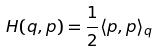<formula> <loc_0><loc_0><loc_500><loc_500>H ( q , p ) = \frac { 1 } { 2 } \langle p , p \rangle _ { q }</formula> 